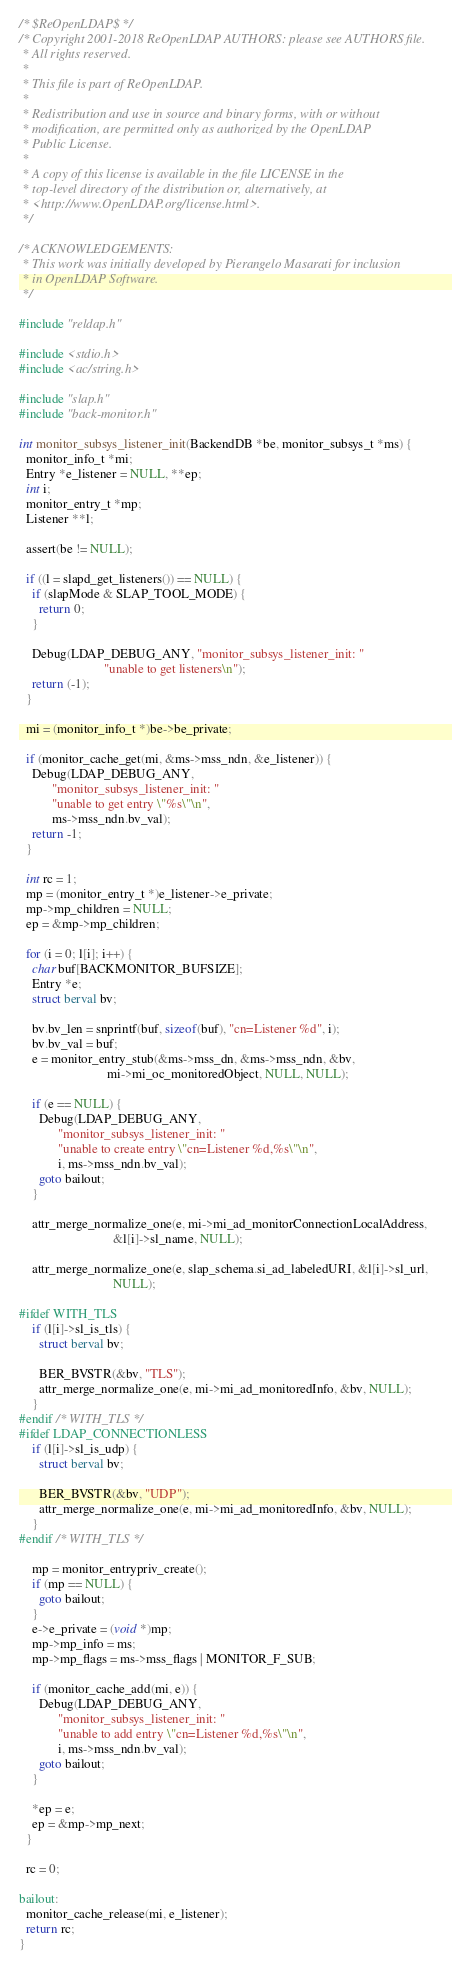<code> <loc_0><loc_0><loc_500><loc_500><_C_>/* $ReOpenLDAP$ */
/* Copyright 2001-2018 ReOpenLDAP AUTHORS: please see AUTHORS file.
 * All rights reserved.
 *
 * This file is part of ReOpenLDAP.
 *
 * Redistribution and use in source and binary forms, with or without
 * modification, are permitted only as authorized by the OpenLDAP
 * Public License.
 *
 * A copy of this license is available in the file LICENSE in the
 * top-level directory of the distribution or, alternatively, at
 * <http://www.OpenLDAP.org/license.html>.
 */

/* ACKNOWLEDGEMENTS:
 * This work was initially developed by Pierangelo Masarati for inclusion
 * in OpenLDAP Software.
 */

#include "reldap.h"

#include <stdio.h>
#include <ac/string.h>

#include "slap.h"
#include "back-monitor.h"

int monitor_subsys_listener_init(BackendDB *be, monitor_subsys_t *ms) {
  monitor_info_t *mi;
  Entry *e_listener = NULL, **ep;
  int i;
  monitor_entry_t *mp;
  Listener **l;

  assert(be != NULL);

  if ((l = slapd_get_listeners()) == NULL) {
    if (slapMode & SLAP_TOOL_MODE) {
      return 0;
    }

    Debug(LDAP_DEBUG_ANY, "monitor_subsys_listener_init: "
                          "unable to get listeners\n");
    return (-1);
  }

  mi = (monitor_info_t *)be->be_private;

  if (monitor_cache_get(mi, &ms->mss_ndn, &e_listener)) {
    Debug(LDAP_DEBUG_ANY,
          "monitor_subsys_listener_init: "
          "unable to get entry \"%s\"\n",
          ms->mss_ndn.bv_val);
    return -1;
  }

  int rc = 1;
  mp = (monitor_entry_t *)e_listener->e_private;
  mp->mp_children = NULL;
  ep = &mp->mp_children;

  for (i = 0; l[i]; i++) {
    char buf[BACKMONITOR_BUFSIZE];
    Entry *e;
    struct berval bv;

    bv.bv_len = snprintf(buf, sizeof(buf), "cn=Listener %d", i);
    bv.bv_val = buf;
    e = monitor_entry_stub(&ms->mss_dn, &ms->mss_ndn, &bv,
                           mi->mi_oc_monitoredObject, NULL, NULL);

    if (e == NULL) {
      Debug(LDAP_DEBUG_ANY,
            "monitor_subsys_listener_init: "
            "unable to create entry \"cn=Listener %d,%s\"\n",
            i, ms->mss_ndn.bv_val);
      goto bailout;
    }

    attr_merge_normalize_one(e, mi->mi_ad_monitorConnectionLocalAddress,
                             &l[i]->sl_name, NULL);

    attr_merge_normalize_one(e, slap_schema.si_ad_labeledURI, &l[i]->sl_url,
                             NULL);

#ifdef WITH_TLS
    if (l[i]->sl_is_tls) {
      struct berval bv;

      BER_BVSTR(&bv, "TLS");
      attr_merge_normalize_one(e, mi->mi_ad_monitoredInfo, &bv, NULL);
    }
#endif /* WITH_TLS */
#ifdef LDAP_CONNECTIONLESS
    if (l[i]->sl_is_udp) {
      struct berval bv;

      BER_BVSTR(&bv, "UDP");
      attr_merge_normalize_one(e, mi->mi_ad_monitoredInfo, &bv, NULL);
    }
#endif /* WITH_TLS */

    mp = monitor_entrypriv_create();
    if (mp == NULL) {
      goto bailout;
    }
    e->e_private = (void *)mp;
    mp->mp_info = ms;
    mp->mp_flags = ms->mss_flags | MONITOR_F_SUB;

    if (monitor_cache_add(mi, e)) {
      Debug(LDAP_DEBUG_ANY,
            "monitor_subsys_listener_init: "
            "unable to add entry \"cn=Listener %d,%s\"\n",
            i, ms->mss_ndn.bv_val);
      goto bailout;
    }

    *ep = e;
    ep = &mp->mp_next;
  }

  rc = 0;

bailout:
  monitor_cache_release(mi, e_listener);
  return rc;
}
</code> 